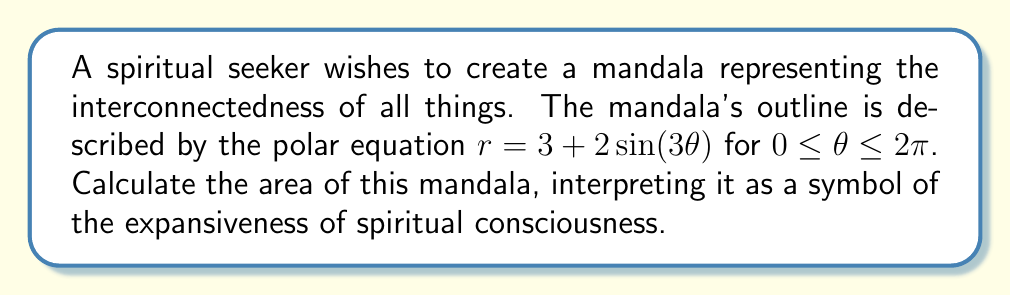Could you help me with this problem? To calculate the area of the mandala, we need to use polar integration. The formula for the area of a region bounded by a polar curve $r = f(\theta)$ from $\theta = a$ to $\theta = b$ is:

$$A = \frac{1}{2} \int_{a}^{b} [f(\theta)]^2 d\theta$$

For our mandala:
$r = 3 + 2\sin(3\theta)$
$a = 0$
$b = 2\pi$

Let's proceed step by step:

1) First, we square the function:
   $[f(\theta)]^2 = (3 + 2\sin(3\theta))^2 = 9 + 12\sin(3\theta) + 4\sin^2(3\theta)$

2) Now, we set up the integral:
   $$A = \frac{1}{2} \int_{0}^{2\pi} (9 + 12\sin(3\theta) + 4\sin^2(3\theta)) d\theta$$

3) Let's integrate each term separately:
   
   a) $\int_{0}^{2\pi} 9 d\theta = 9\theta |_{0}^{2\pi} = 18\pi$
   
   b) $\int_{0}^{2\pi} 12\sin(3\theta) d\theta = -4\cos(3\theta) |_{0}^{2\pi} = 0$
   
   c) For the $\sin^2$ term, we can use the identity $\sin^2(x) = \frac{1}{2}(1-\cos(2x))$:
      
      $\int_{0}^{2\pi} 4\sin^2(3\theta) d\theta = \int_{0}^{2\pi} 2(1-\cos(6\theta)) d\theta$
      $= 2\theta - \frac{1}{3}\sin(6\theta) |_{0}^{2\pi} = 4\pi$

4) Adding these results:
   $A = \frac{1}{2}(18\pi + 0 + 4\pi) = 11\pi$

Thus, the area of the mandala is $11\pi$ square units.
Answer: $11\pi$ square units 